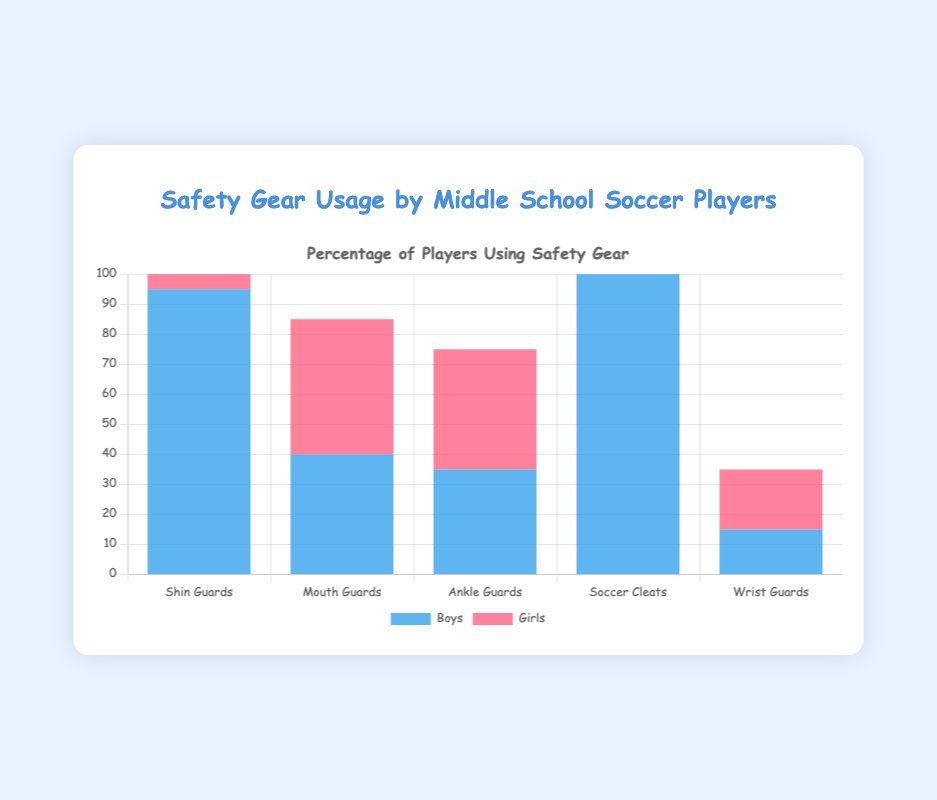What percentage of girls use shin guards? Identify the data point for girls using shin guards in the chart. The chart shows that 97% of girls use shin guards.
Answer: 97% How much more frequently do girls use mouth guards compared to boys? Look at the data points for mouth guard usage for both boys and girls. The chart shows that 45% of girls and 40% of boys use mouth guards. The difference is 45% - 40% = 5%.
Answer: 5% What is the average percentage usage of ankle guards for boys and girls? Identify the data points for ankle guard usage for boys and girls. Boys have 35% usage and girls have 40% usage. The average is (35 + 40) / 2 = 37.5%.
Answer: 37.5% Which gender uses wrist guards more frequently and by how much? Compare the wrist guard usage percentages for boys and girls. Boys have a usage of 15% and girls have 20%. Girls use wrist guards more frequently by 20% - 15% = 5%.
Answer: Girls, 5% What percentage of total players use shin guards (combining boys and girls)? Sum the percentages of boys and girls using shin guards and divide by 2 for the average. 95% of boys and 97% of girls use shin guards. The average is (95 + 97) / 2 = 96%.
Answer: 96% Which safety gear has a higher percentage usage by boys than by girls? Examine the data points to see where boys have a higher percentage than girls. Boys have higher usage in Shin Guards (95%), Ankle Guards (35%), and Wrist Guards (15%) compared to girls’ 97%, 40%, and 20% respectively. None of these show higher percentage usages in boys compared to girls in the data provided.
Answer: None 